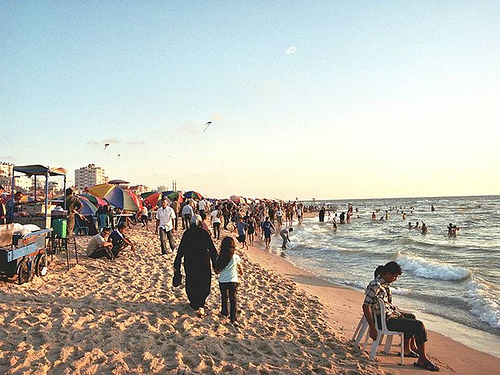What is the piece of furniture on the beach? The piece of furniture on the beach is a simple, solitary chair, set against the scenic backdrop of the bustling beach and gentle ocean waves. 